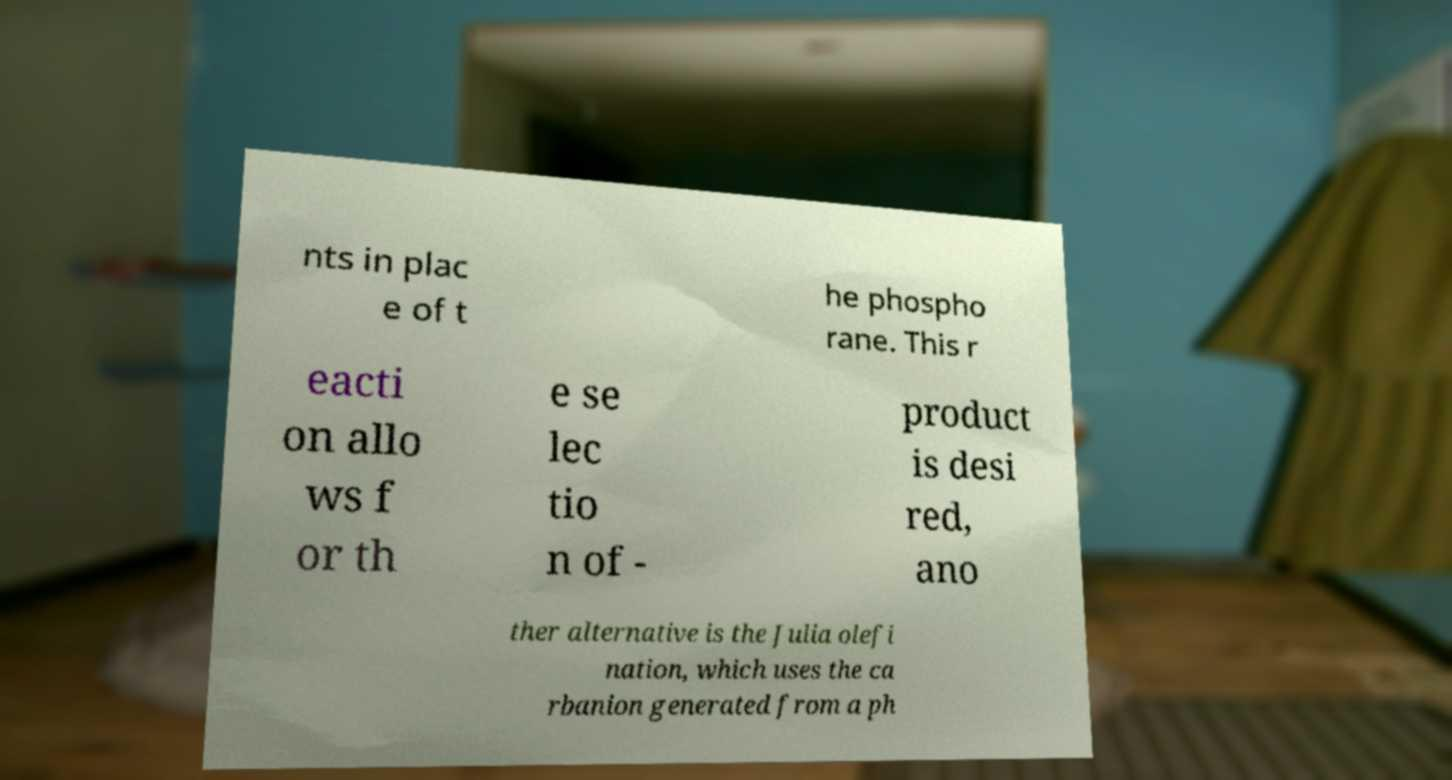Please read and relay the text visible in this image. What does it say? nts in plac e of t he phospho rane. This r eacti on allo ws f or th e se lec tio n of - product is desi red, ano ther alternative is the Julia olefi nation, which uses the ca rbanion generated from a ph 